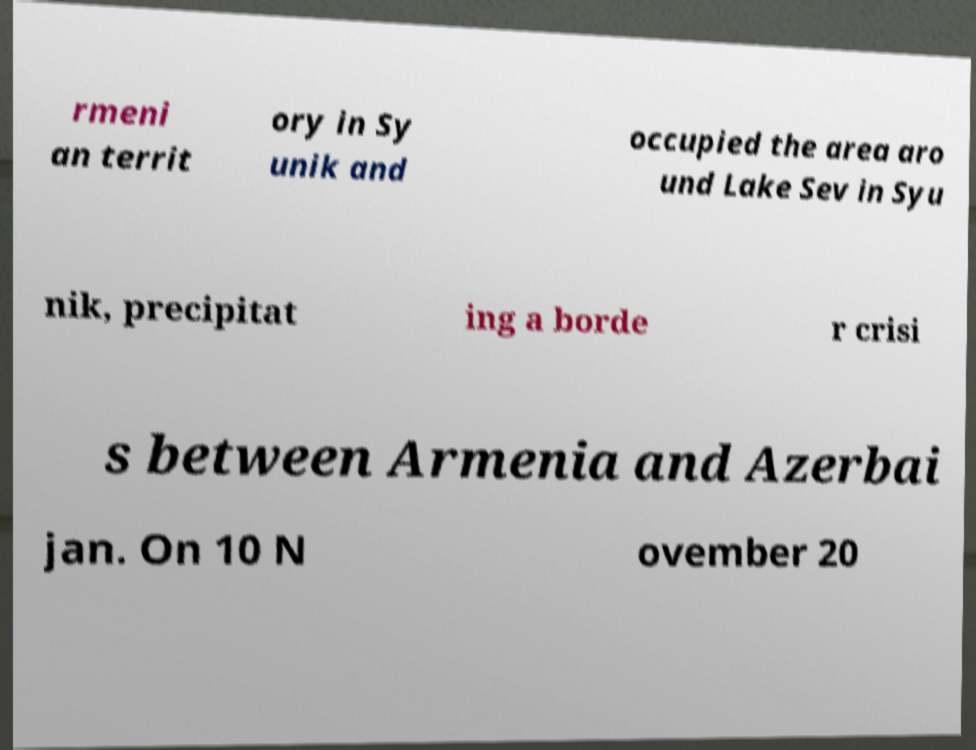I need the written content from this picture converted into text. Can you do that? rmeni an territ ory in Sy unik and occupied the area aro und Lake Sev in Syu nik, precipitat ing a borde r crisi s between Armenia and Azerbai jan. On 10 N ovember 20 